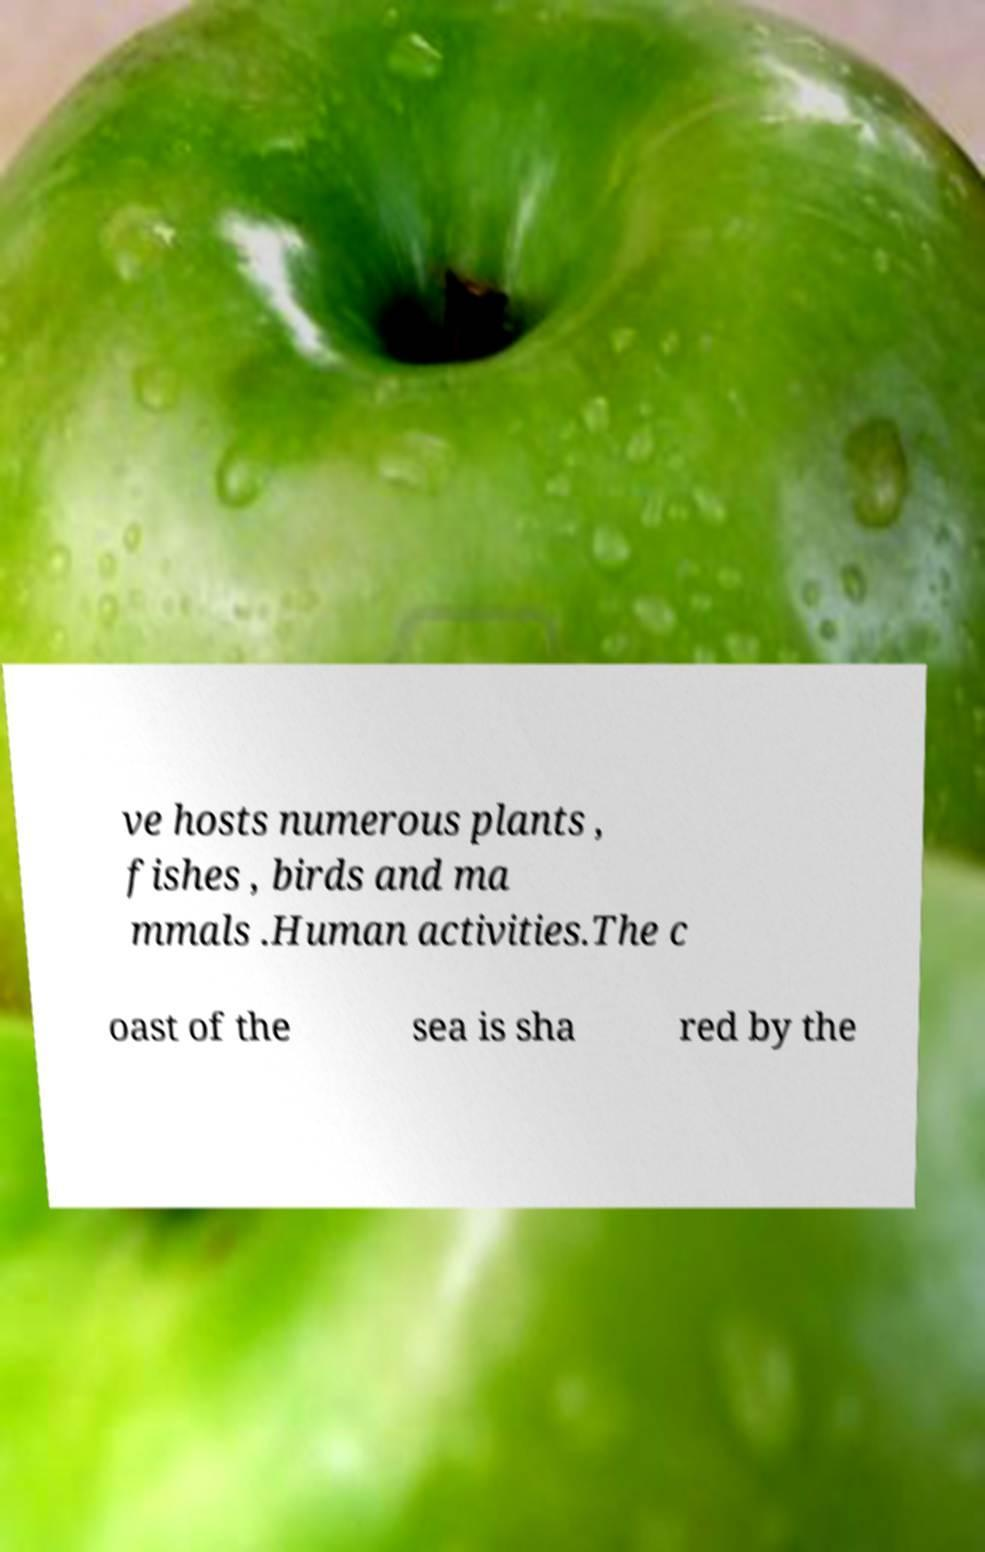Can you read and provide the text displayed in the image?This photo seems to have some interesting text. Can you extract and type it out for me? ve hosts numerous plants , fishes , birds and ma mmals .Human activities.The c oast of the sea is sha red by the 